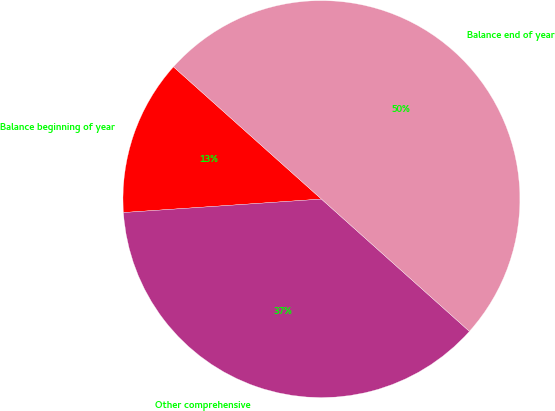Convert chart to OTSL. <chart><loc_0><loc_0><loc_500><loc_500><pie_chart><fcel>Balance beginning of year<fcel>Other comprehensive<fcel>Balance end of year<nl><fcel>12.69%<fcel>37.31%<fcel>50.0%<nl></chart> 